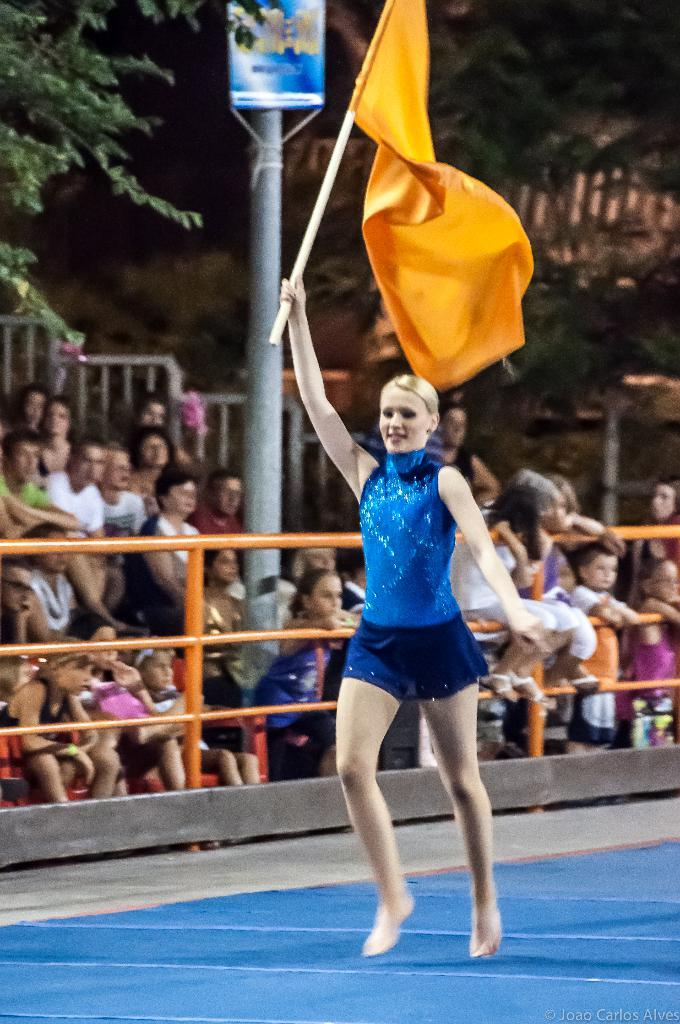Who is the main subject in the image? There is a woman in the image. What is the woman wearing? The woman is wearing a blue dress. What is the woman holding in the image? The woman is holding a flag. What can be seen in the background of the image? There is a group of people sitting, an iron barricade, a pole, and a group of trees in the background. What shape are the tomatoes in the image? There are no tomatoes present in the image. What disease is the woman suffering from in the image? There is no indication in the image that the woman is suffering from any disease. 